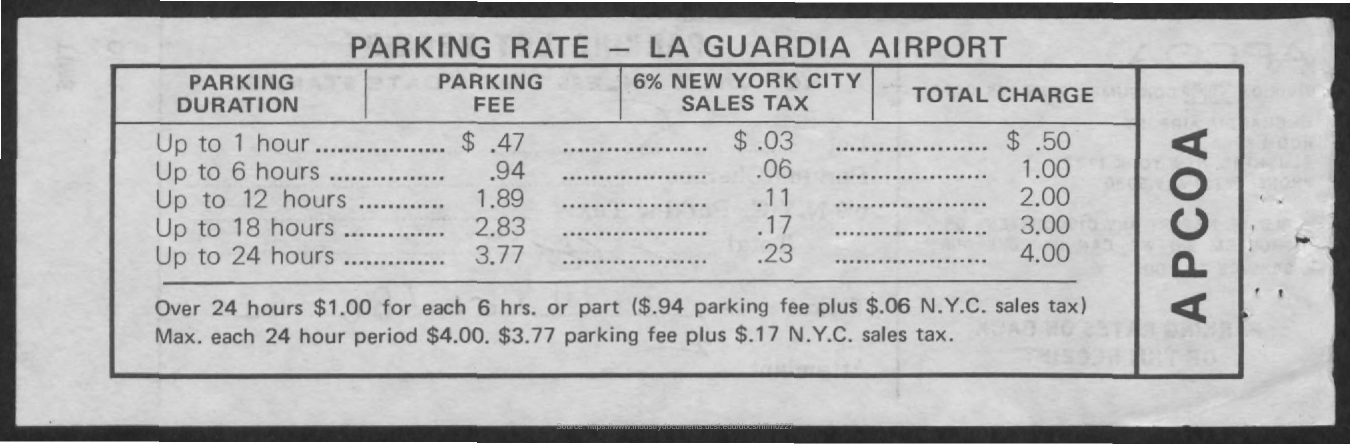List a handful of essential elements in this visual. The total charge for parking without sales tax for up to 24 hours is $3.77. The total cost for parking for up to 1 hour is 50 cents. 